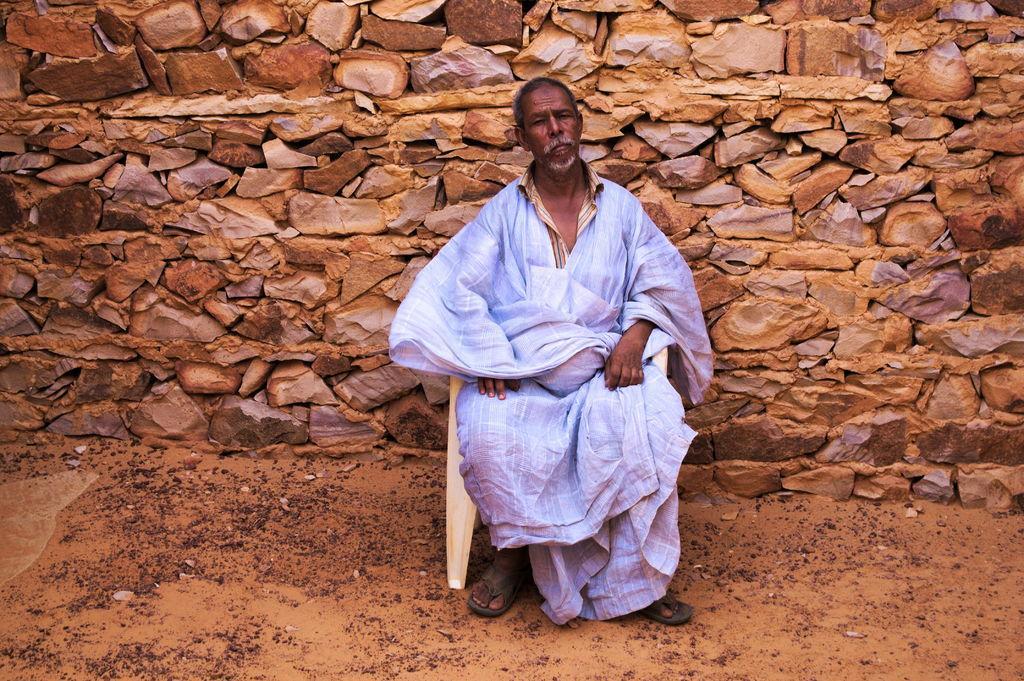Can you describe this image briefly? In the center of the image we can see person sitting on the chair. In the background we can see wall. 